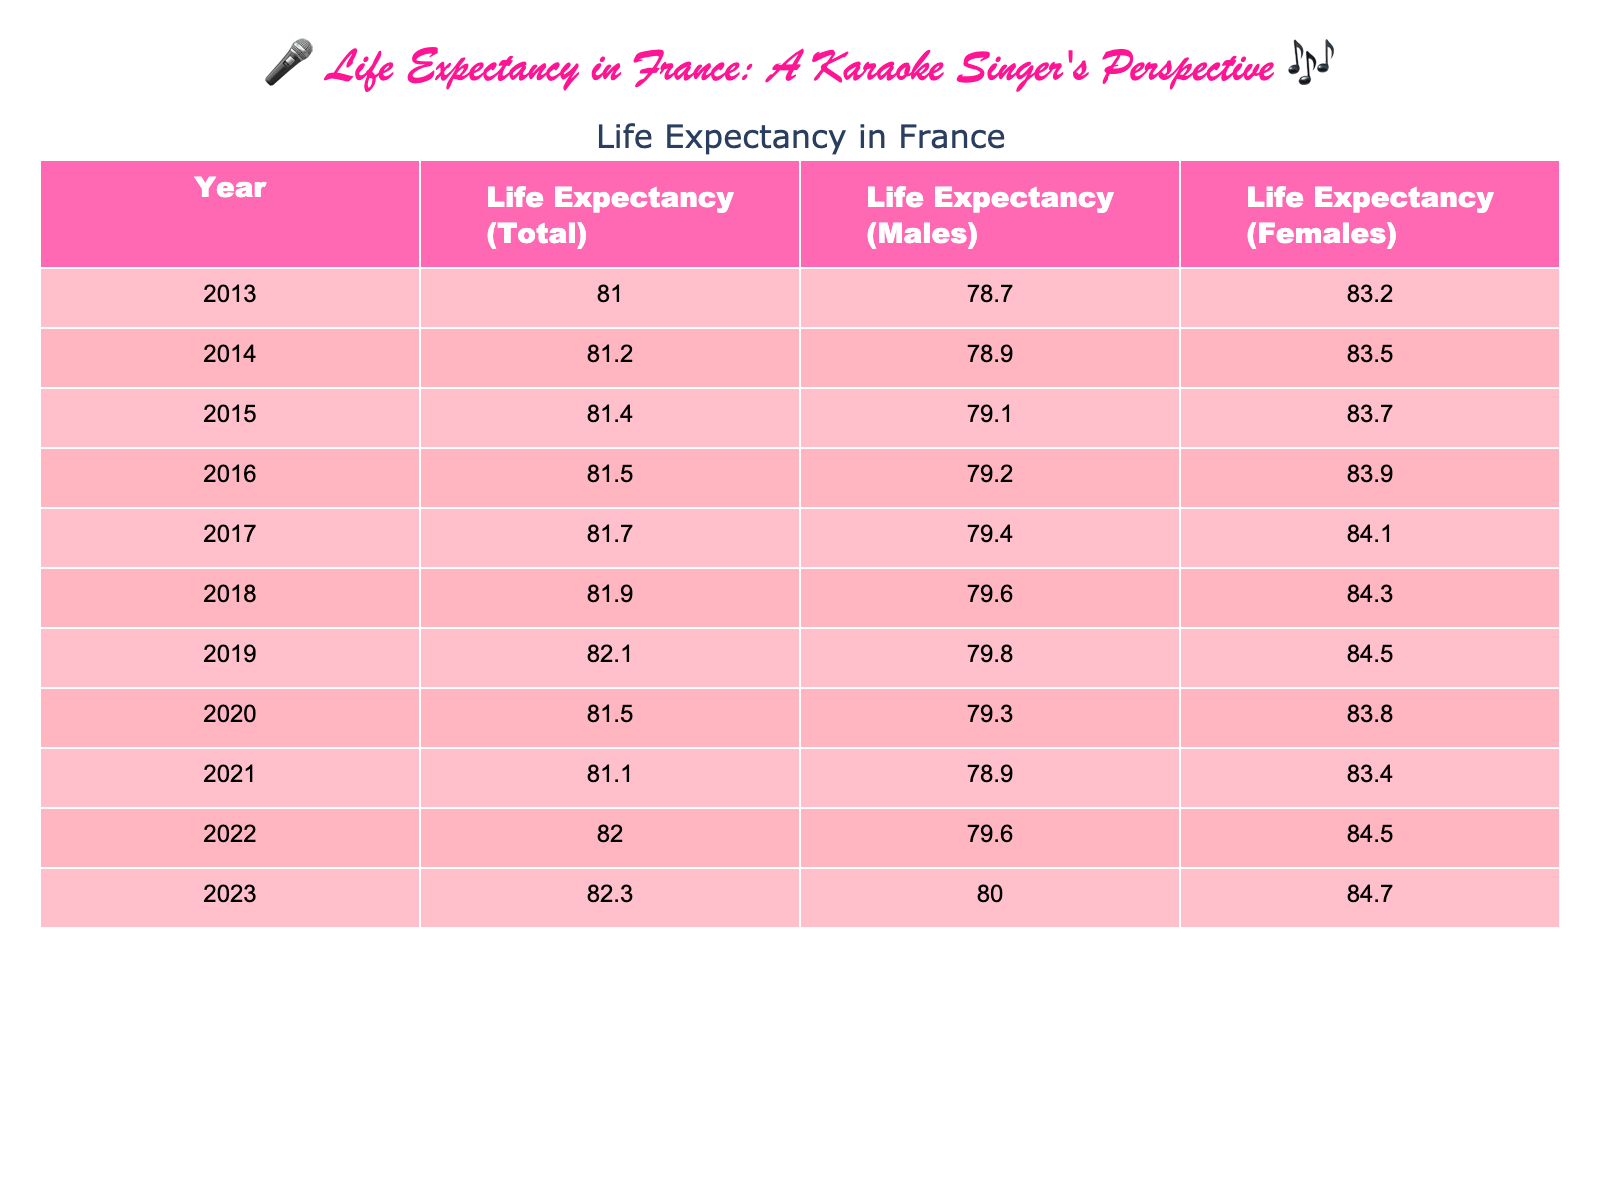What was the life expectancy in France in 2015? In the table, look at the year 2015, which shows a life expectancy total of 81.4.
Answer: 81.4 How does the life expectancy for males compare to females in 2022? In 2022, the life expectancy for males is 79.6 and for females it is 84.5. The difference is 84.5 - 79.6 = 4.9 years.
Answer: 4.9 years What year had the highest life expectancy recorded? Scanning through the table, the highest life expectancy is in 2023, which shows 82.3 years.
Answer: 82.3 Was the life expectancy for females higher than for males in 2019? In the year 2019, the life expectancy for females is 84.5 while for males it is 79.8, confirming that females had a higher life expectancy.
Answer: Yes What is the average life expectancy for the years 2019, 2020, and 2021 combined? To find the average, sum the life expectancies from those years: 82.1 + 81.5 + 81.1 = 244.7. Then divide by 3: 244.7 / 3 = 81.5667.
Answer: 81.57 Which year experienced a decrease in life expectancy for total, males, or females? Comparing the years, 2020 shows a decrease in total life expectancy (81.5) from 2019 (82.1), and for males, it also dropped from 79.8 to 79.3.
Answer: Yes Did the life expectancy for males increase every year from 2013 to 2023? Looking at the data from 2013 to 2023, we notice that male life expectancy decreased in 2020 and in 2021. Therefore, it did not increase every year.
Answer: No What is the difference in life expectancy between males and females in the year 2018? In 2018, life expectancy for males is 79.6 and for females is 84.3, which gives a difference of 84.3 - 79.6 = 4.7 years.
Answer: 4.7 years In which year did the life expectancy of females first exceed 84 years? By examining the table, we see that females first exceeded 84 years in 2019 when it reached 84.5.
Answer: 2019 